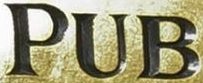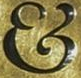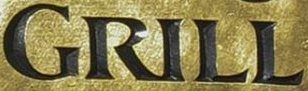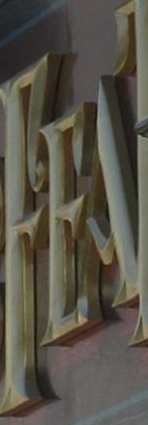What words can you see in these images in sequence, separated by a semicolon? PUB; &; GRILL; FEA 